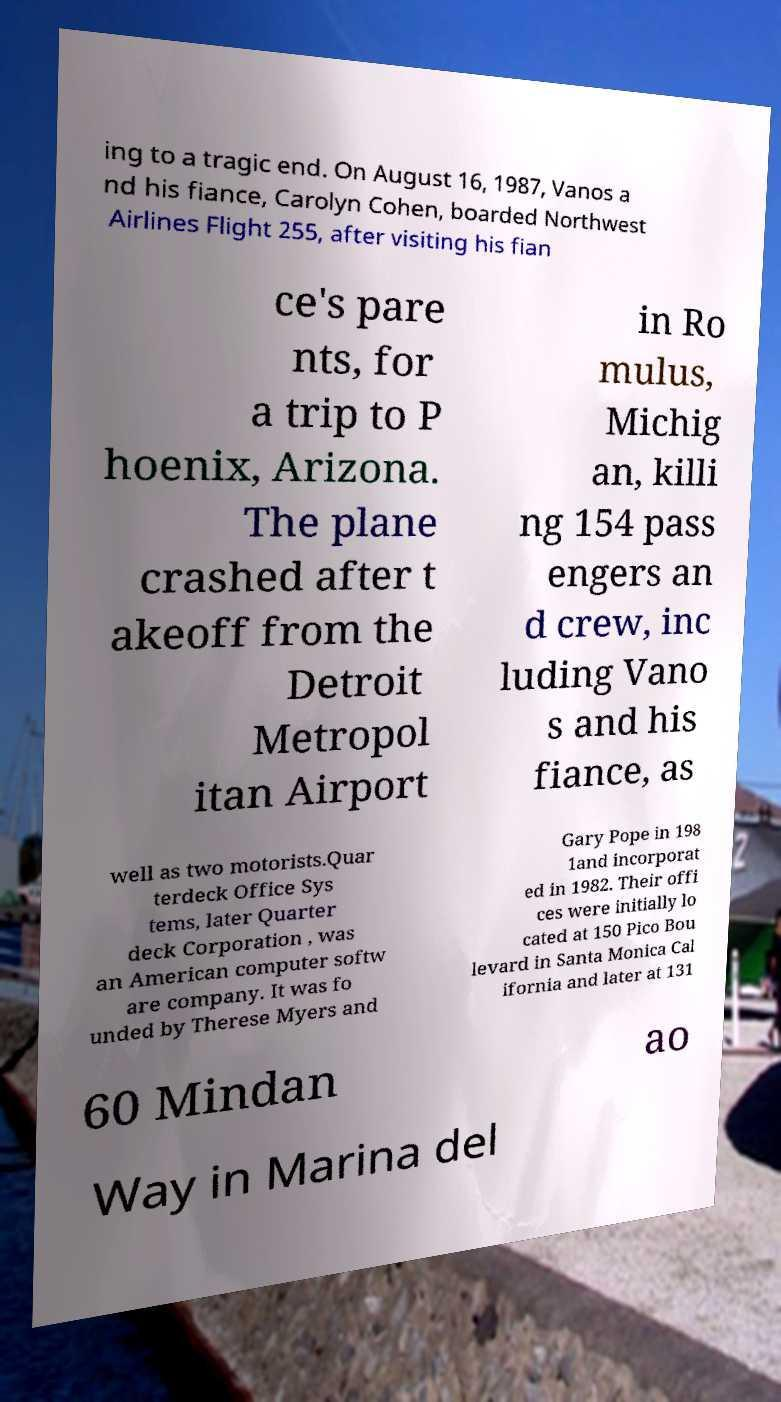Can you read and provide the text displayed in the image?This photo seems to have some interesting text. Can you extract and type it out for me? ing to a tragic end. On August 16, 1987, Vanos a nd his fiance, Carolyn Cohen, boarded Northwest Airlines Flight 255, after visiting his fian ce's pare nts, for a trip to P hoenix, Arizona. The plane crashed after t akeoff from the Detroit Metropol itan Airport in Ro mulus, Michig an, killi ng 154 pass engers an d crew, inc luding Vano s and his fiance, as well as two motorists.Quar terdeck Office Sys tems, later Quarter deck Corporation , was an American computer softw are company. It was fo unded by Therese Myers and Gary Pope in 198 1and incorporat ed in 1982. Their offi ces were initially lo cated at 150 Pico Bou levard in Santa Monica Cal ifornia and later at 131 60 Mindan ao Way in Marina del 